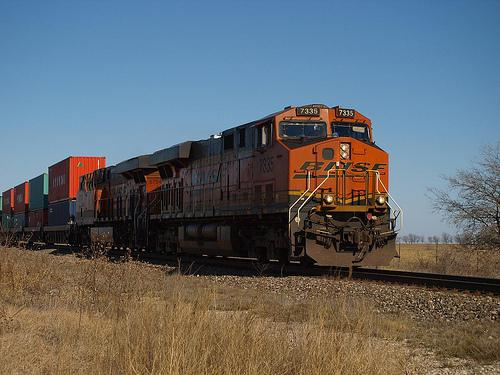Question: how many sets of tracks are there?
Choices:
A. Two.
B. Three.
C. None.
D. One.
Answer with the letter. Answer: D Question: what is the sky like?
Choices:
A. Cloudy and gray.
B. Blue and clear.
C. Dark and rainy.
D. Snowy and blue.
Answer with the letter. Answer: B Question: what is the vehicle pictured?
Choices:
A. A train.
B. A bus.
C. A taxi.
D. A car.
Answer with the letter. Answer: A Question: who drive the train?
Choices:
A. The conductor.
B. The pilot.
C. The doctor.
D. The passenger.
Answer with the letter. Answer: A 